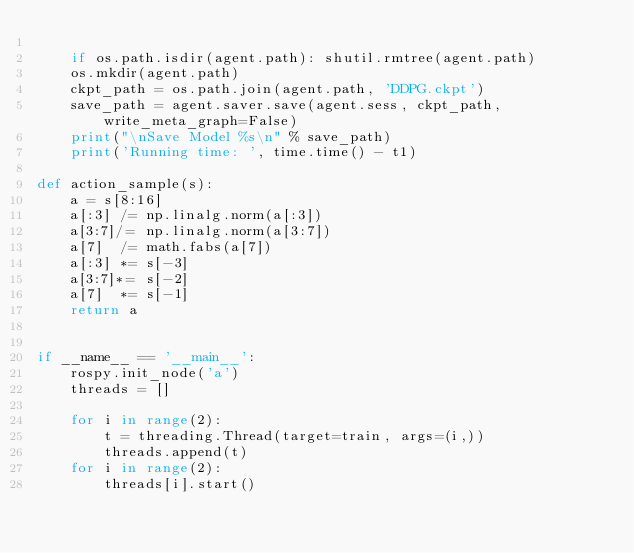<code> <loc_0><loc_0><loc_500><loc_500><_Python_>
    if os.path.isdir(agent.path): shutil.rmtree(agent.path)
    os.mkdir(agent.path)
    ckpt_path = os.path.join(agent.path, 'DDPG.ckpt')
    save_path = agent.saver.save(agent.sess, ckpt_path, write_meta_graph=False)
    print("\nSave Model %s\n" % save_path)
    print('Running time: ', time.time() - t1)

def action_sample(s):
    a = s[8:16]
    a[:3] /= np.linalg.norm(a[:3])
    a[3:7]/= np.linalg.norm(a[3:7])
    a[7]  /= math.fabs(a[7])
    a[:3] *= s[-3]
    a[3:7]*= s[-2]
    a[7]  *= s[-1]
    return a


if __name__ == '__main__':
    rospy.init_node('a')
    threads = []
    
    for i in range(2):
        t = threading.Thread(target=train, args=(i,))
        threads.append(t)
    for i in range(2):
        threads[i].start()</code> 